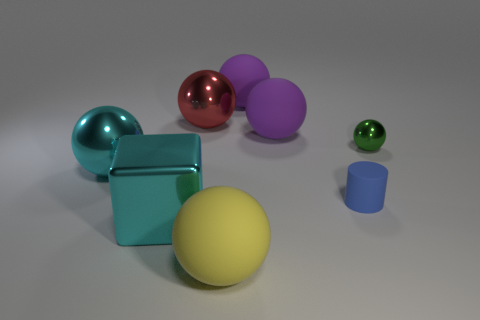Subtract all cyan shiny balls. How many balls are left? 5 Subtract all red balls. How many balls are left? 5 Subtract 1 cubes. How many cubes are left? 0 Subtract 0 gray cubes. How many objects are left? 8 Subtract all cubes. How many objects are left? 7 Subtract all red spheres. Subtract all green cylinders. How many spheres are left? 5 Subtract all brown cylinders. How many cyan spheres are left? 1 Subtract all large yellow matte balls. Subtract all red things. How many objects are left? 6 Add 4 big purple balls. How many big purple balls are left? 6 Add 8 green spheres. How many green spheres exist? 9 